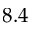<formula> <loc_0><loc_0><loc_500><loc_500>8 . 4</formula> 